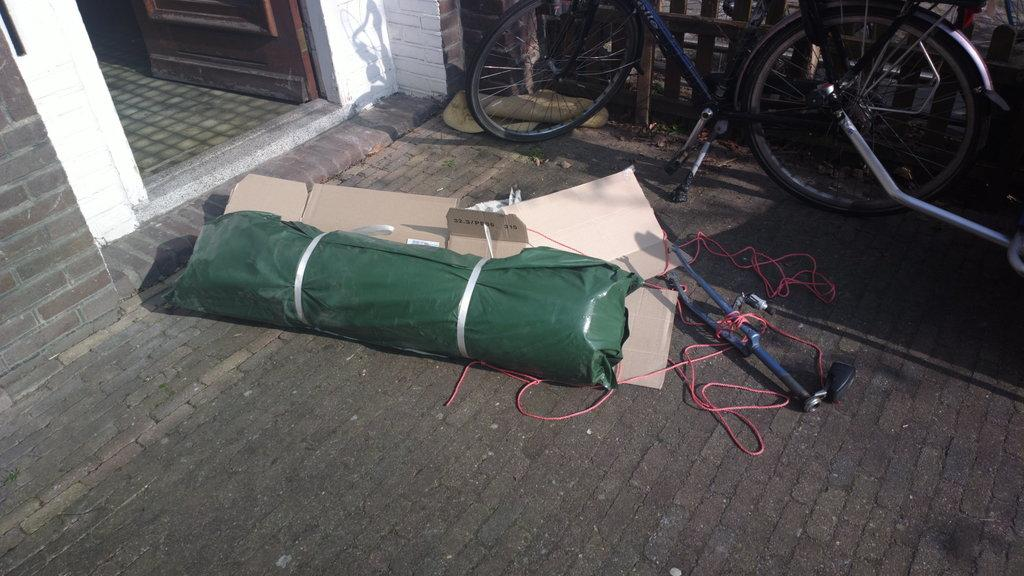What is covered or protected in the image? There is a cover in the image. What type of material is visible in the image? There are cardboards in the image. What object can be seen on the floor in the image? There is an object placed on the floor in the image. What mode of transportation is present in the image? There is a bicycle in the image. What architectural feature is present in the image? There is a fence in the image. What entrance or exit is visible in the image? There is a door in the image. What structural element is present in the image? There is a wall in the image. Can you tell me how many boats are docked near the wall in the image? There are no boats present in the image; it features a bicycle, a fence, a door, and a wall. What type of soda is being served in the image? There is no soda present in the image. What type of furniture can be seen in the bedroom in the image? There is no bedroom present in the image. 